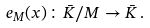<formula> <loc_0><loc_0><loc_500><loc_500>e _ { M } ( x ) \colon \bar { K } / M \to \bar { K } \, .</formula> 